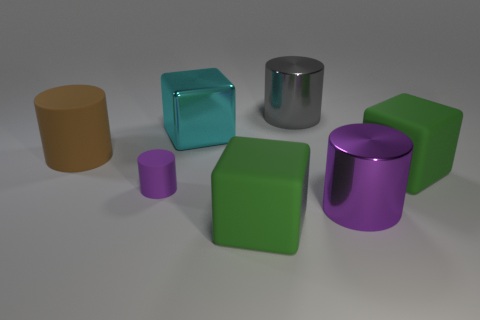Subtract all large cylinders. How many cylinders are left? 1 Add 2 small gray rubber balls. How many objects exist? 9 Subtract all cyan cubes. How many cubes are left? 2 Subtract all cylinders. How many objects are left? 3 Subtract 1 cubes. How many cubes are left? 2 Subtract all gray metal objects. Subtract all large brown metal cylinders. How many objects are left? 6 Add 3 metal things. How many metal things are left? 6 Add 1 green things. How many green things exist? 3 Subtract 0 yellow spheres. How many objects are left? 7 Subtract all gray cylinders. Subtract all yellow balls. How many cylinders are left? 3 